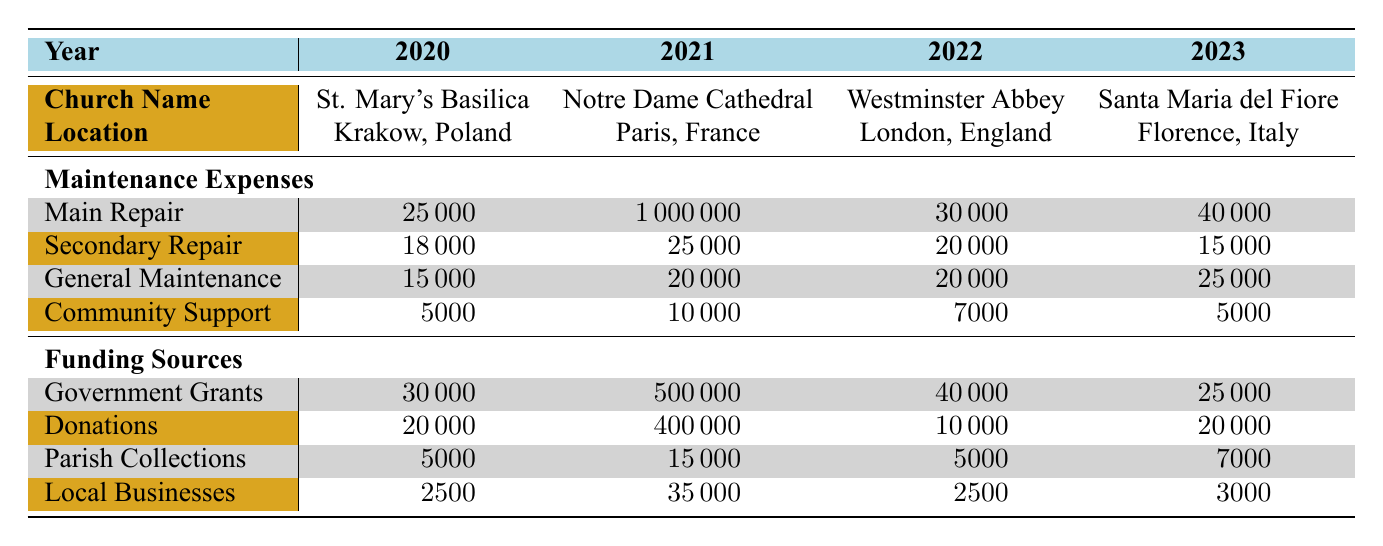What were the total maintenance expenses for Notre Dame Cathedral in 2021? The maintenance expenses for Notre Dame Cathedral in 2021 can be found by adding the values of Fire Damage Restoration (1000000), Stone Work (25000), General Maintenance (20000), and Community Support (10000). So, the total is 1000000 + 25000 + 20000 + 10000 = 1030000.
Answer: 1030000 Which church had the highest funding from Government Grants in 2021? Looking at the Government Grants row for each church in 2021, Notre Dame Cathedral received 500000, the highest amount compared to others.
Answer: Notre Dame Cathedral Did Santa Maria del Fiore have higher total maintenance expenses than St. Mary's Basilica? First, we calculate the maintenance expenses for Santa Maria del Fiore: Marble Facade Cleaning (40000), Bell Tower Repair (15000), General Maintenance (25000), and Community Support (5000) totaling 40000 + 15000 + 25000 + 5000 = 85000. For St. Mary's Basilica: Roof Repair (25000), Stained Glass Restoration (18000), General Maintenance (15000), and Community Support (5000) totals to 25000 + 18000 + 15000 + 5000 = 63000. Since 85000 > 63000, Santa Maria del Fiore does have higher expenses.
Answer: Yes What was the average total funding from Local Businesses for all churches from 2020 to 2023? First, we sum the Local Businesses funding for each year: 2500 (2020) + 35000 (2021) + 2500 (2022) + 3000 (2023) = 43500. There are four churches, so to find the average, we divide by 4: 43500 / 4 = 10875.
Answer: 10875 Which church had the highest total funding in 2021, and how much was it? By reviewing the total funding sources for 2021, we can calculate the totals for Notre Dame Cathedral: Government Grants (500000) + International Donations (400000) + Parish Collections (15000) + Local Businesses (35000) = 971000. This is greater than any other church funding in any other year.
Answer: Notre Dame Cathedral, 971000 Was the funding from Private Donations for Westminster Abbey in 2022 less than the funding from Government Grants for the same year? The Private Donations for Westminster Abbey in 2022 was 10000 while the Government Grants were 40000. Since 10000 is less than 40000, the statement is true.
Answer: Yes 